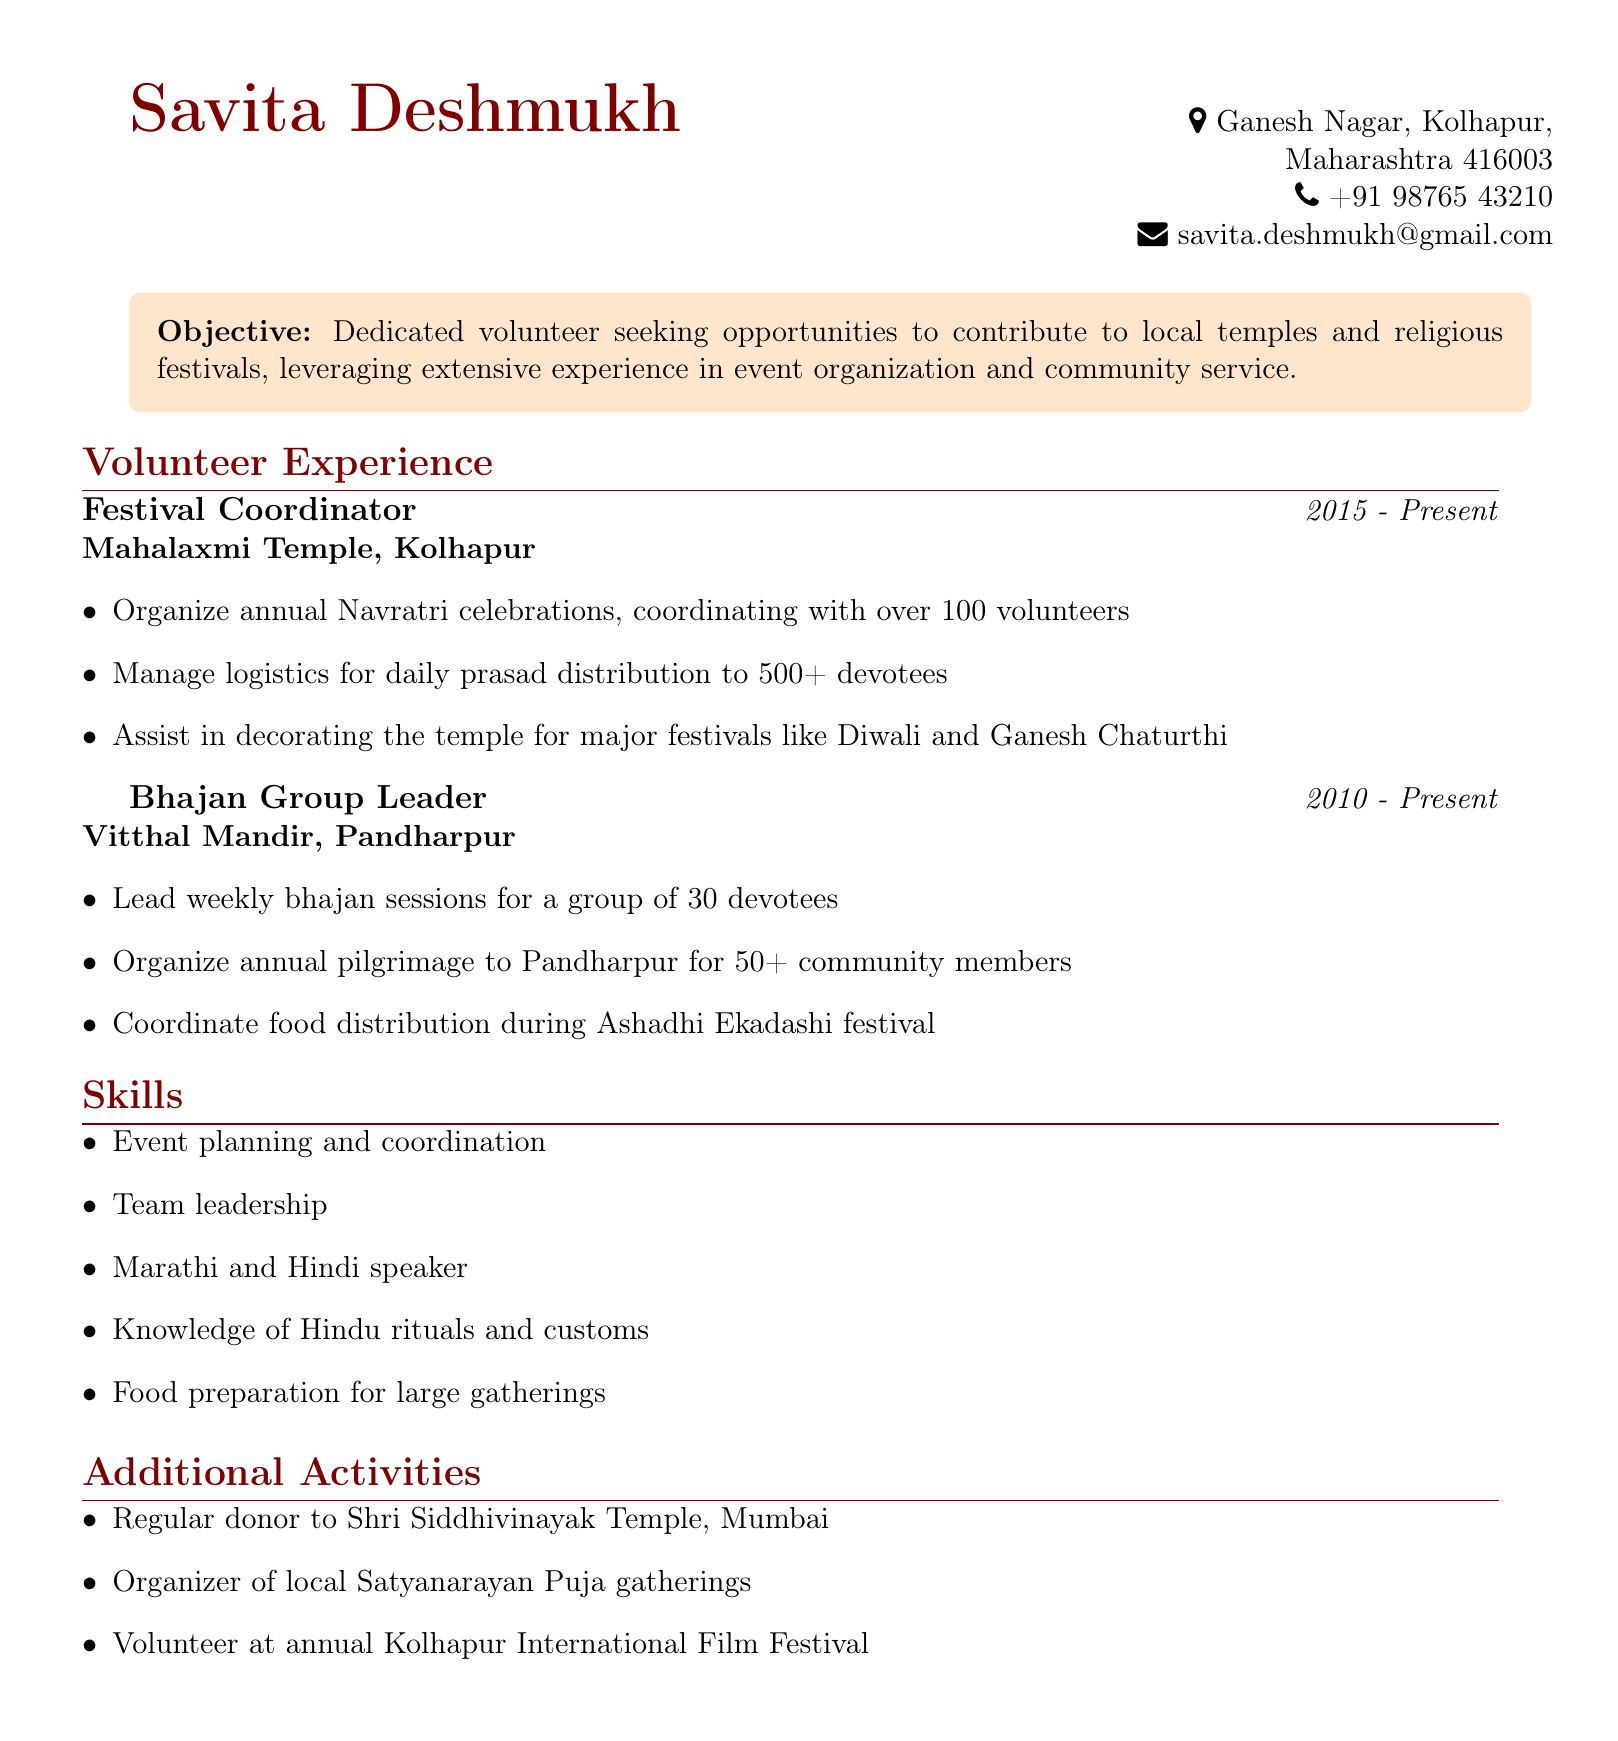What is Savita Deshmukh's phone number? The phone number is located in the personal info section of the CV.
Answer: +91 98765 43210 What is Savita's role at Mahalaxmi Temple? The role is listed under volunteer experience, specifically noted as the Festival Coordinator.
Answer: Festival Coordinator How many years has Savita been a Bhajan Group Leader? This is calculated by taking the current year (assumed 2023) minus the start year listed (2010).
Answer: 13 years What major festival does Savita help organize at Mahalaxmi Temple? The major festival mentioned in the responsibilities is annual Navratri celebrations.
Answer: Navratri How many devotees does Savita distribute prasad to daily during the festivals? This number is found in the responsibilities under the Festival Coordinator position.
Answer: 500+ What community activity does Savita coordinate for Ashadhi Ekadashi? This is mentioned under her responsibilities as Bhajan Group Leader.
Answer: Food distribution What skills does Savita possess related to event management? The skills listed in the document highlight her strengths in event planning and coordination.
Answer: Event planning and coordination Where has Savita organized local puja gatherings? The specific gathering mentioned in the additional activities section points to a local event.
Answer: Satyanarayan Puja What type of volunteer work does Savita do at the Kolhapur International Film Festival? This is mentioned in the additional activities section of the CV.
Answer: Volunteer 